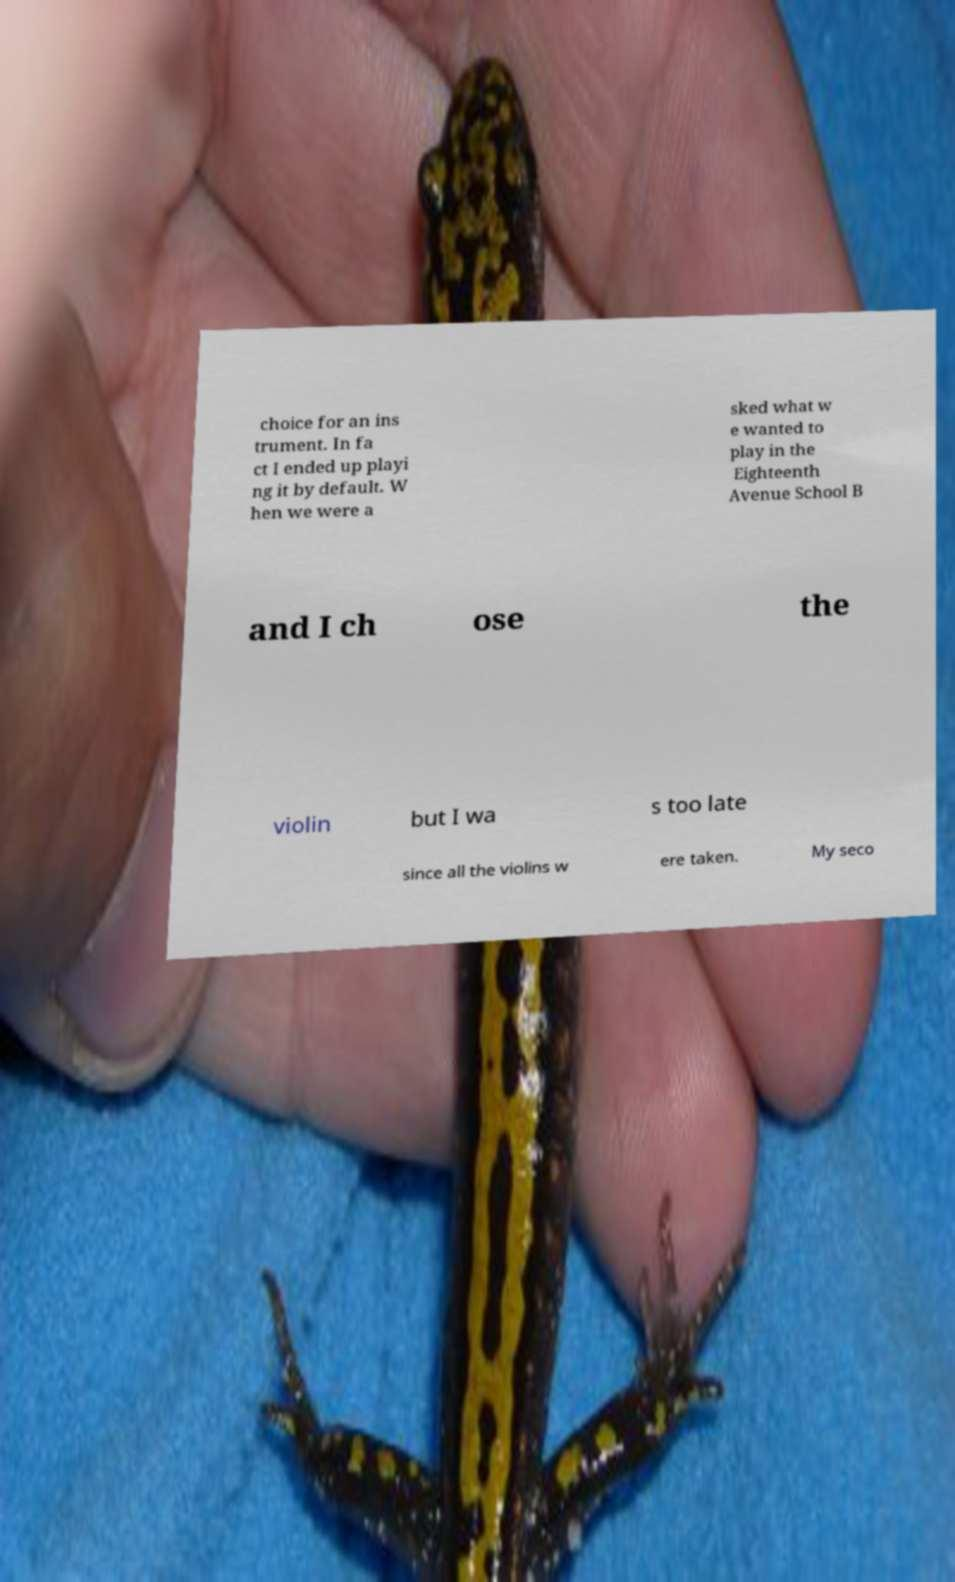Can you accurately transcribe the text from the provided image for me? choice for an ins trument. In fa ct I ended up playi ng it by default. W hen we were a sked what w e wanted to play in the Eighteenth Avenue School B and I ch ose the violin but I wa s too late since all the violins w ere taken. My seco 